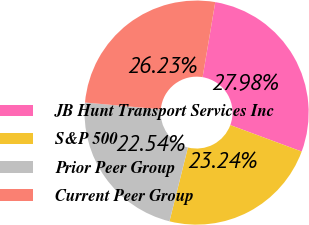Convert chart. <chart><loc_0><loc_0><loc_500><loc_500><pie_chart><fcel>JB Hunt Transport Services Inc<fcel>S&P 500<fcel>Prior Peer Group<fcel>Current Peer Group<nl><fcel>27.98%<fcel>23.24%<fcel>22.54%<fcel>26.23%<nl></chart> 